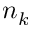Convert formula to latex. <formula><loc_0><loc_0><loc_500><loc_500>n _ { k }</formula> 